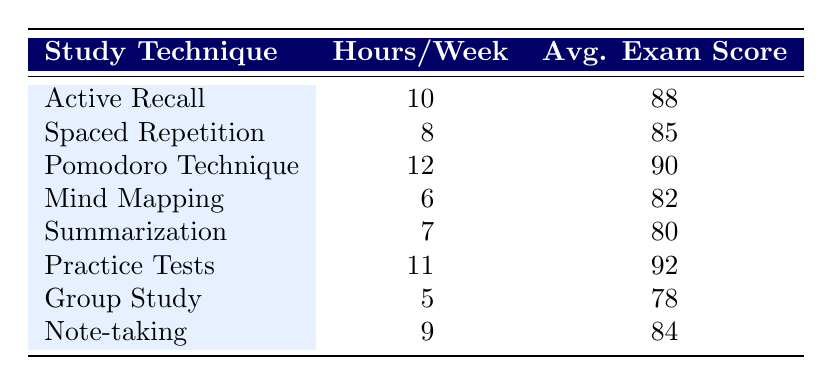What is the average exam score for the Active Recall study technique? The exam score for Active Recall is specifically listed as 88 in the table.
Answer: 88 Which study technique had the highest average exam score? The highest average exam score in the table is 92 for Practice Tests.
Answer: Practice Tests What is the total number of hours spent studying for the Pomodoro Technique and Practice Tests combined? The hours spent for Pomodoro Technique is 12 and for Practice Tests is 11. Summing these gives 12 + 11 = 23 hours.
Answer: 23 Is the average exam score for Group Study greater than that of Mind Mapping? The average exam score for Group Study is 78, while for Mind Mapping it is 82. Since 78 is not greater than 82, the statement is false.
Answer: No What is the median average exam score of all study techniques? First, list the average exam scores in ascending order: 78, 80, 82, 84, 85, 88, 90, 92. Since there are 8 scores (an even number), the median will be the average of the 4th and 5th scores, which are 84 and 85. Therefore, (84 + 85) / 2 = 84.5.
Answer: 84.5 How many study techniques have an average exam score above 85? The study techniques with scores above 85 are: Active Recall (88), Pomodoro Technique (90), and Practice Tests (92). This gives a total of 3 techniques.
Answer: 3 What is the range of hours spent per week studying among all techniques? The minimum hours spent is 5 (Group Study) and the maximum is 12 (Pomodoro Technique). The range is calculated by subtracting the minimum from the maximum: 12 - 5 = 7 hours.
Answer: 7 Which study technique falls in the middle of the ranking when ordered by average exam scores? When ordered by average exam scores: 78, 80, 82, 84, 85, 88, 90, 92, the middle scores are the 4th and 5th (84 and 85), indicating that the techniques Mind Mapping and Spaced Repetition represent the middle of the ranking.
Answer: Mind Mapping and Spaced Repetition How many more hours does the Pomodoro Technique require compared to Group Study? The Pomodoro Technique requires 12 hours, while Group Study requires 5 hours. The difference is 12 - 5 = 7 hours more.
Answer: 7 